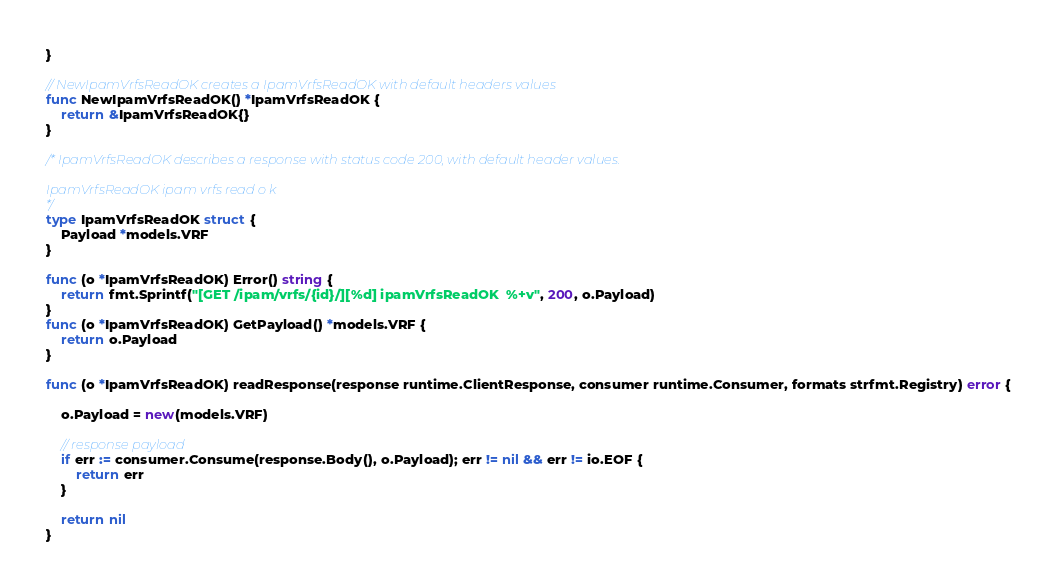<code> <loc_0><loc_0><loc_500><loc_500><_Go_>}

// NewIpamVrfsReadOK creates a IpamVrfsReadOK with default headers values
func NewIpamVrfsReadOK() *IpamVrfsReadOK {
	return &IpamVrfsReadOK{}
}

/* IpamVrfsReadOK describes a response with status code 200, with default header values.

IpamVrfsReadOK ipam vrfs read o k
*/
type IpamVrfsReadOK struct {
	Payload *models.VRF
}

func (o *IpamVrfsReadOK) Error() string {
	return fmt.Sprintf("[GET /ipam/vrfs/{id}/][%d] ipamVrfsReadOK  %+v", 200, o.Payload)
}
func (o *IpamVrfsReadOK) GetPayload() *models.VRF {
	return o.Payload
}

func (o *IpamVrfsReadOK) readResponse(response runtime.ClientResponse, consumer runtime.Consumer, formats strfmt.Registry) error {

	o.Payload = new(models.VRF)

	// response payload
	if err := consumer.Consume(response.Body(), o.Payload); err != nil && err != io.EOF {
		return err
	}

	return nil
}
</code> 